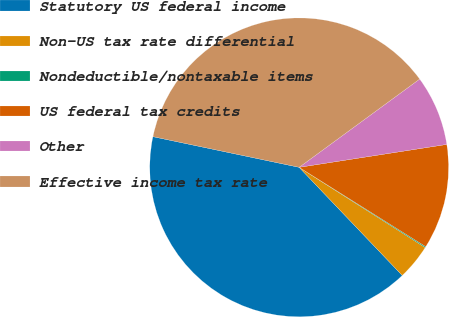<chart> <loc_0><loc_0><loc_500><loc_500><pie_chart><fcel>Statutory US federal income<fcel>Non-US tax rate differential<fcel>Nondeductible/nontaxable items<fcel>US federal tax credits<fcel>Other<fcel>Effective income tax rate<nl><fcel>40.41%<fcel>3.86%<fcel>0.11%<fcel>11.36%<fcel>7.61%<fcel>36.65%<nl></chart> 